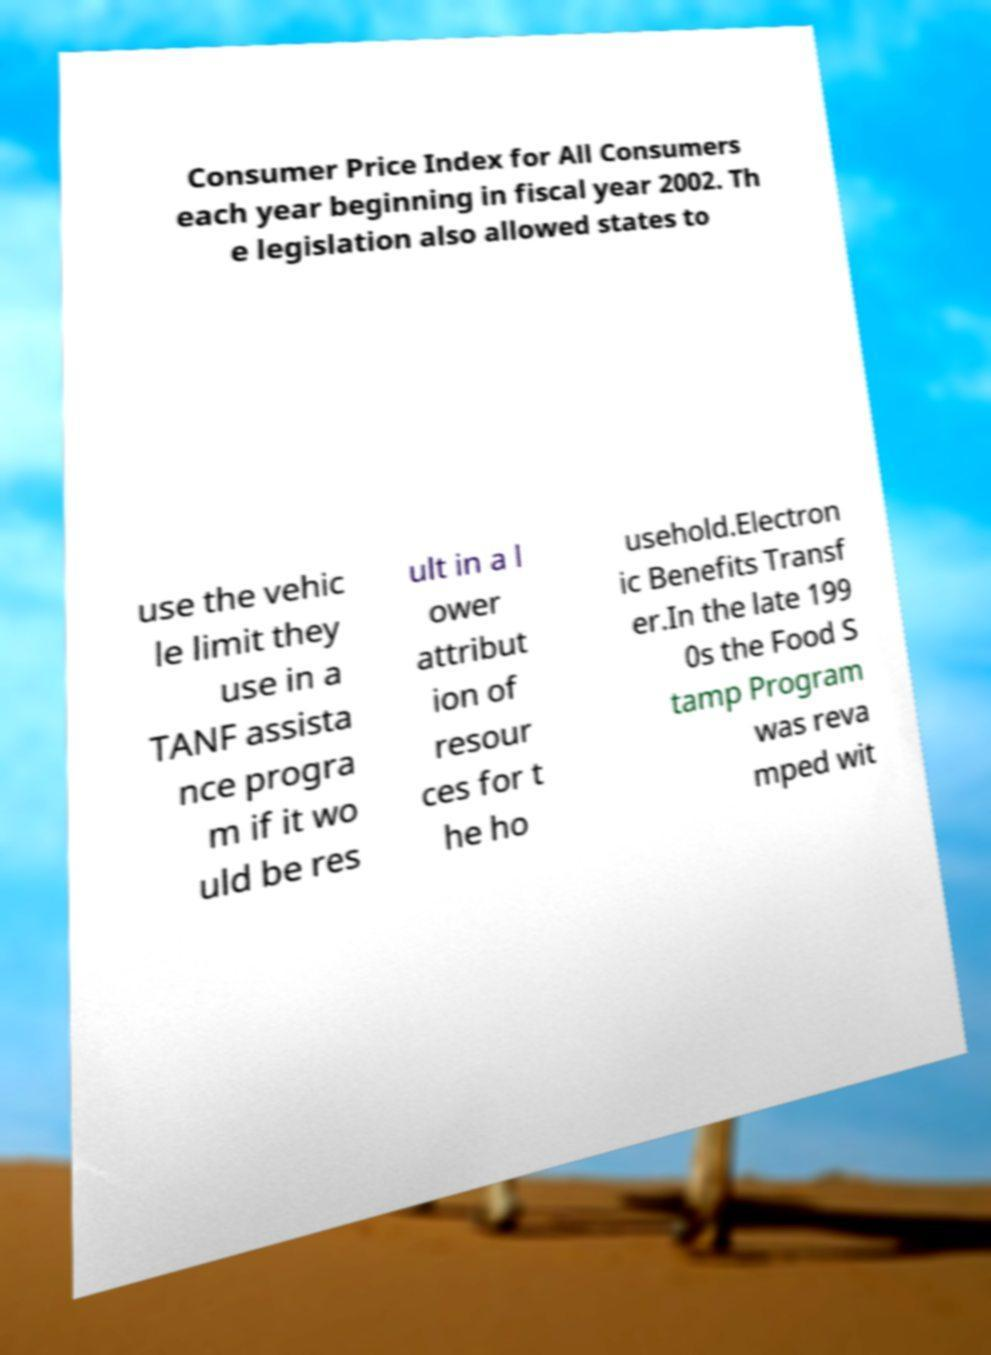Please read and relay the text visible in this image. What does it say? Consumer Price Index for All Consumers each year beginning in fiscal year 2002. Th e legislation also allowed states to use the vehic le limit they use in a TANF assista nce progra m if it wo uld be res ult in a l ower attribut ion of resour ces for t he ho usehold.Electron ic Benefits Transf er.In the late 199 0s the Food S tamp Program was reva mped wit 